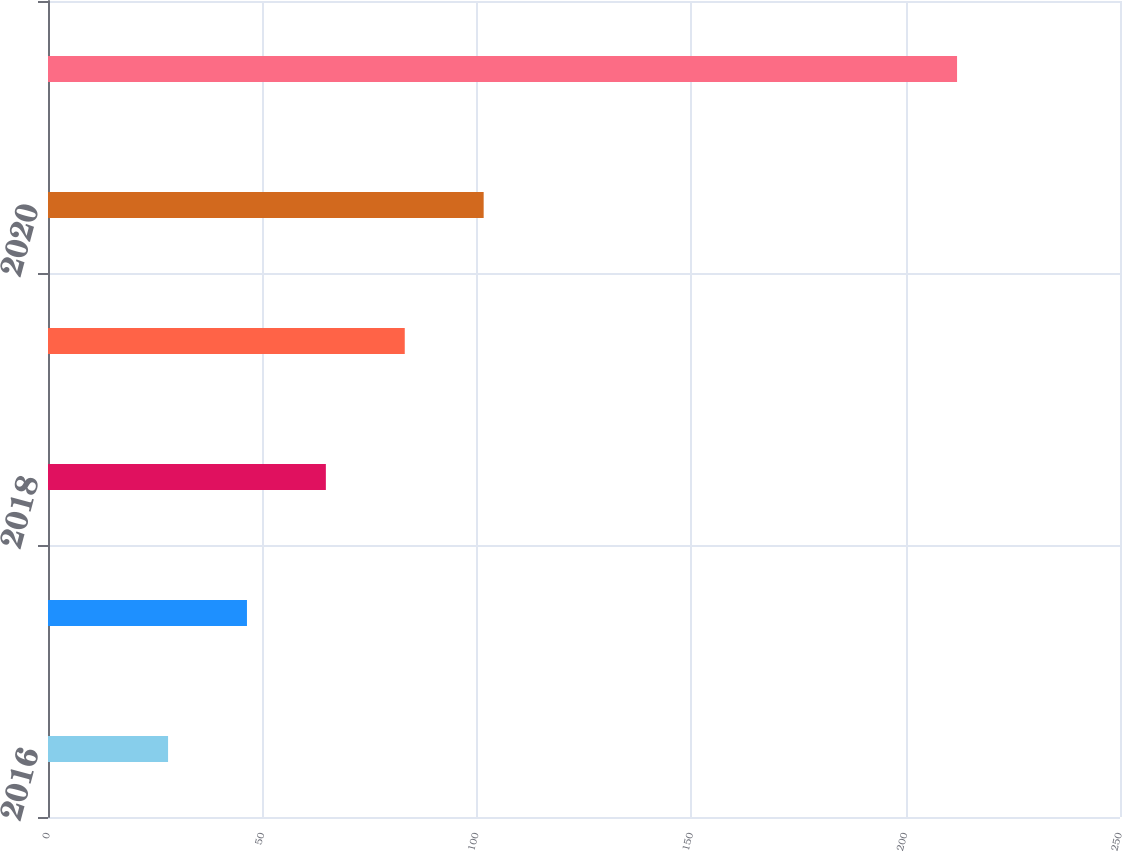<chart> <loc_0><loc_0><loc_500><loc_500><bar_chart><fcel>2016<fcel>2017<fcel>2018<fcel>2019<fcel>2020<fcel>2021-2025<nl><fcel>28<fcel>46.4<fcel>64.8<fcel>83.2<fcel>101.6<fcel>212<nl></chart> 